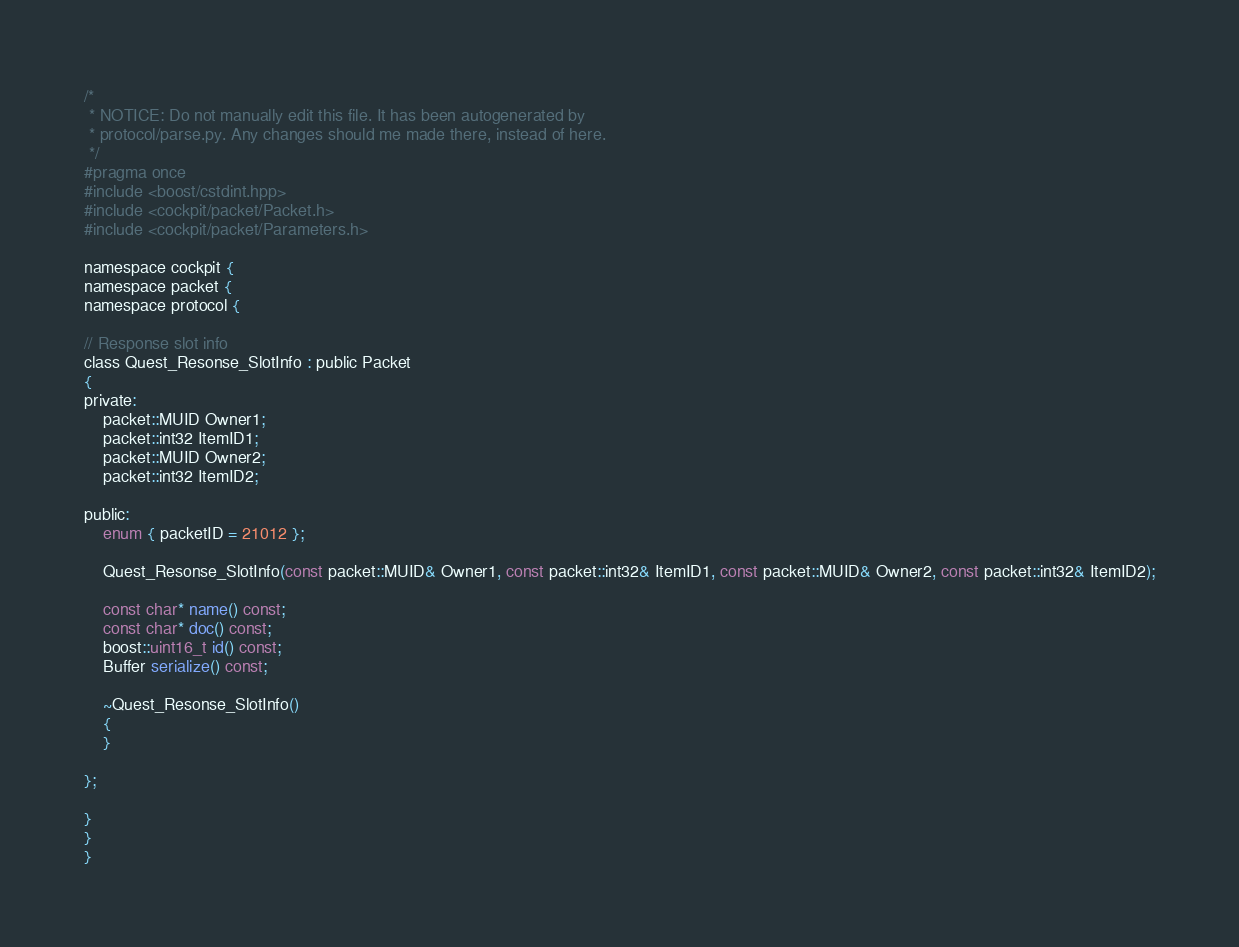<code> <loc_0><loc_0><loc_500><loc_500><_C_>/*
 * NOTICE: Do not manually edit this file. It has been autogenerated by
 * protocol/parse.py. Any changes should me made there, instead of here.
 */
#pragma once
#include <boost/cstdint.hpp>
#include <cockpit/packet/Packet.h>
#include <cockpit/packet/Parameters.h>

namespace cockpit {
namespace packet {
namespace protocol {

// Response slot info
class Quest_Resonse_SlotInfo : public Packet
{
private:
	packet::MUID Owner1;
	packet::int32 ItemID1;
	packet::MUID Owner2;
	packet::int32 ItemID2;

public:
	enum { packetID = 21012 };

	Quest_Resonse_SlotInfo(const packet::MUID& Owner1, const packet::int32& ItemID1, const packet::MUID& Owner2, const packet::int32& ItemID2);

	const char* name() const;
	const char* doc() const;
	boost::uint16_t id() const;
	Buffer serialize() const;

	~Quest_Resonse_SlotInfo()
	{
	}

};

}
}
}
</code> 